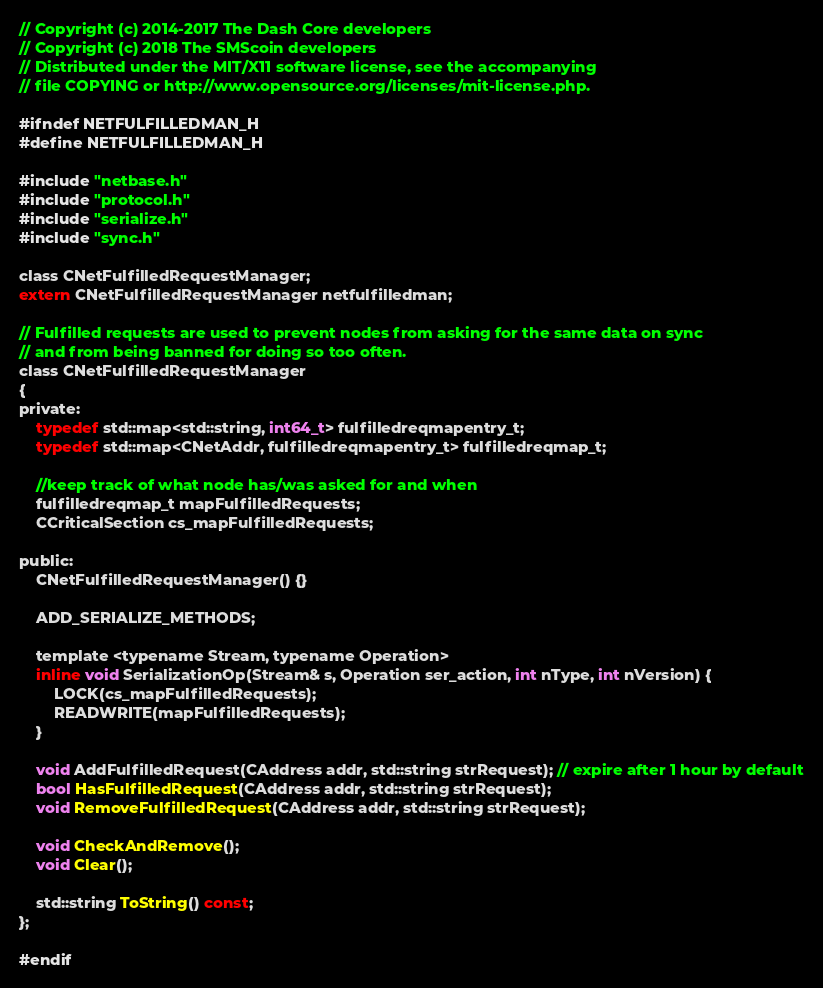<code> <loc_0><loc_0><loc_500><loc_500><_C_>// Copyright (c) 2014-2017 The Dash Core developers
// Copyright (c) 2018 The SMScoin developers
// Distributed under the MIT/X11 software license, see the accompanying
// file COPYING or http://www.opensource.org/licenses/mit-license.php.

#ifndef NETFULFILLEDMAN_H
#define NETFULFILLEDMAN_H

#include "netbase.h"
#include "protocol.h"
#include "serialize.h"
#include "sync.h"

class CNetFulfilledRequestManager;
extern CNetFulfilledRequestManager netfulfilledman;

// Fulfilled requests are used to prevent nodes from asking for the same data on sync
// and from being banned for doing so too often.
class CNetFulfilledRequestManager
{
private:
    typedef std::map<std::string, int64_t> fulfilledreqmapentry_t;
    typedef std::map<CNetAddr, fulfilledreqmapentry_t> fulfilledreqmap_t;

    //keep track of what node has/was asked for and when
    fulfilledreqmap_t mapFulfilledRequests;
    CCriticalSection cs_mapFulfilledRequests;

public:
    CNetFulfilledRequestManager() {}

    ADD_SERIALIZE_METHODS;

    template <typename Stream, typename Operation>
    inline void SerializationOp(Stream& s, Operation ser_action, int nType, int nVersion) {
        LOCK(cs_mapFulfilledRequests);
        READWRITE(mapFulfilledRequests);
    }

    void AddFulfilledRequest(CAddress addr, std::string strRequest); // expire after 1 hour by default
    bool HasFulfilledRequest(CAddress addr, std::string strRequest);
    void RemoveFulfilledRequest(CAddress addr, std::string strRequest);

    void CheckAndRemove();
    void Clear();

    std::string ToString() const;
};

#endif
</code> 